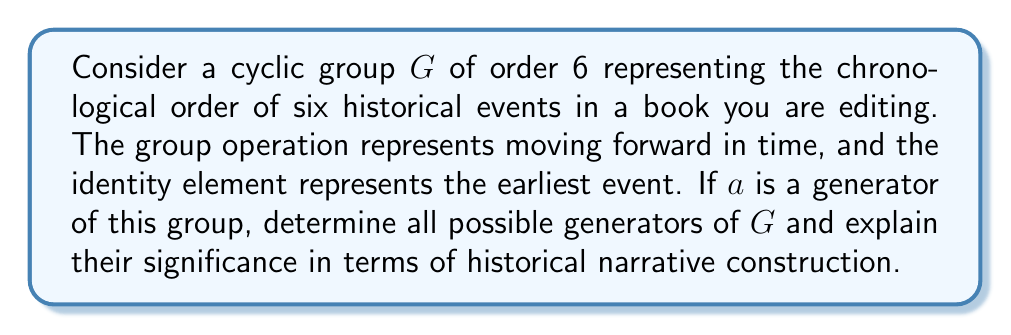Provide a solution to this math problem. Let's approach this step-by-step:

1) In a cyclic group of order 6, the elements can be represented as:
   $$G = \{e, a, a^2, a^3, a^4, a^5\}$$
   where $e$ is the identity element (earliest event) and $a$ is a generator.

2) To find all generators, we need to identify elements that, when raised to powers, generate all elements of the group.

3) For each element $a^k$, we check if $\gcd(k,6) = 1$. If so, $a^k$ is a generator.

4) Let's check each element:
   - $a^1$: $\gcd(1,6) = 1$, so $a$ is a generator
   - $a^2$: $\gcd(2,6) = 2$, not a generator
   - $a^3$: $\gcd(3,6) = 3$, not a generator
   - $a^4$: $\gcd(4,6) = 2$, not a generator
   - $a^5$: $\gcd(5,6) = 1$, so $a^5$ is a generator

5) Therefore, the generators are $a$ and $a^5$.

6) In terms of historical narrative:
   - $a$ represents moving forward one event at a time
   - $a^5$ represents moving backward one event at a time (equivalent to moving forward 5 events in a cycle of 6)

7) These generators allow for different perspectives in constructing the historical narrative:
   - $a$ allows for a chronological telling of events
   - $a^5$ allows for a reverse chronological approach, starting from the most recent event and working backward

This aligns with the editor's belief in the importance of first-hand accounts, as different narrative structures (represented by different generators) can emphasize different perspectives and eyewitness testimonies.
Answer: The generators of the cyclic group $G$ are $a$ and $a^5$. These represent forward and reverse chronological orderings of the historical events, respectively, allowing for flexible narrative construction in the historical account. 